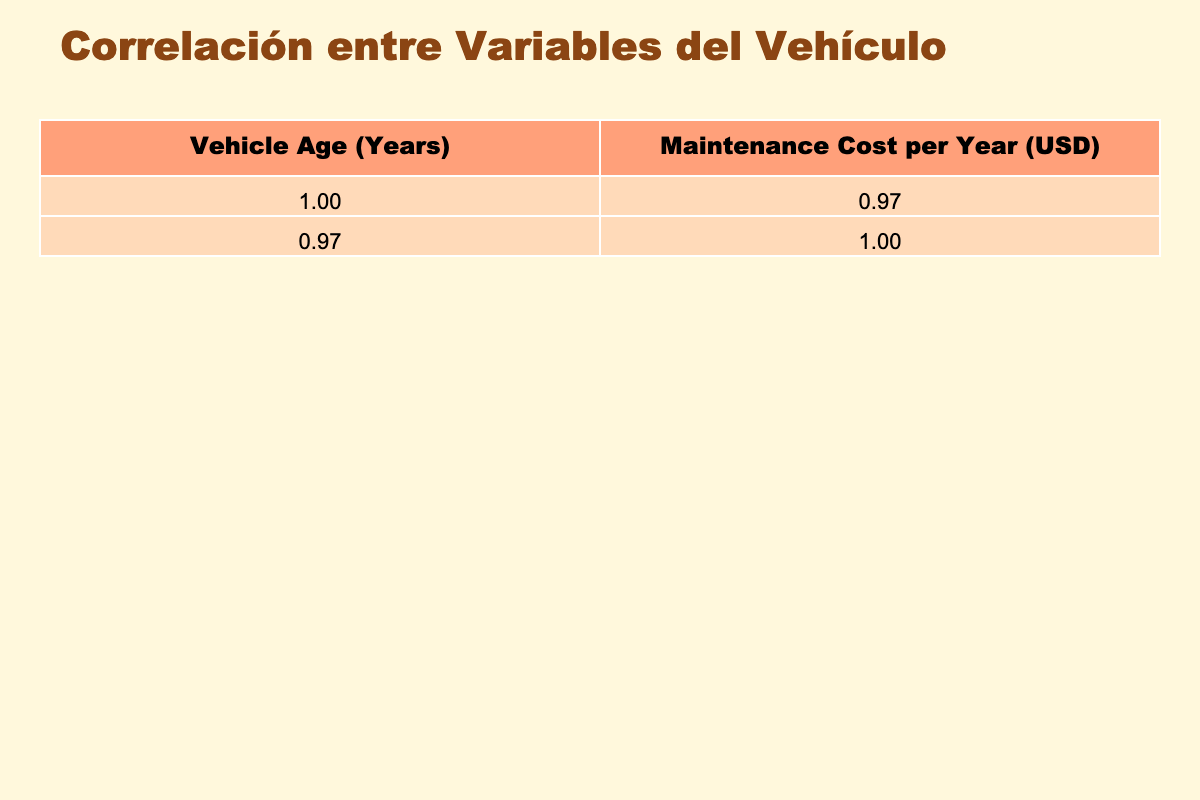What is the maintenance cost for a vehicle that is 3 years old? The table shows that the maintenance cost for a 3-year-old vehicle is listed directly under the "Maintenance Cost per Year" column, corresponding to the row for 3 years. The value is 500 USD.
Answer: 500 USD What is the maintenance cost for the oldest vehicle listed in the table? The oldest vehicle in the table is 15 years old, and by looking at the corresponding row, the maintenance cost is 4200 USD.
Answer: 4200 USD Is the maintenance cost for a 10-year-old vehicle higher than that of a 5-year-old vehicle? From the table, the maintenance cost for a 10-year-old vehicle is 2000 USD, while the cost for a 5-year-old vehicle is 800 USD. Since 2000 is greater than 800, the answer is yes.
Answer: Yes What is the average maintenance cost of vehicles that are 1 to 5 years old? We will sum the maintenance costs for 1 to 5 years (300 + 400 + 500 + 650 + 800) = 2650 USD. There are 5 vehicles, so the average is 2650 / 5 = 530 USD.
Answer: 530 USD What is the difference in maintenance costs between the 12-year-old and the 9-year-old vehicle? The maintenance cost for the 12-year-old vehicle is 2800 USD and for the 9-year-old vehicle, it is 1600 USD. The difference is 2800 - 1600 = 1200 USD.
Answer: 1200 USD Are maintenance costs for older vehicles consistently increasing? Upon examining the maintenance costs listed, they do increase for each subsequent year from 1 to 15, indicating that maintenance costs are indeed consistently rising.
Answer: Yes What is the total maintenance cost for all vehicles aged 6 to 10 years? We will sum the maintenance costs for 6 to 10 years: (950 + 1100 + 1300 + 1600 + 2000) = 4950 USD.
Answer: 4950 USD Is there a vehicle brand associated with the lowest maintenance cost and what is that cost? The table indicates that the vehicle with the lowest maintenance cost is the 1-year-old Chevrolet at 300 USD, making it the lowest among all brands.
Answer: Chevrolet, 300 USD What is the maximum maintenance cost for any vehicle from the data provided? By scanning through the maintenance costs in the table, the maximum value is found for the 15-year-old vehicle at 4200 USD.
Answer: 4200 USD 